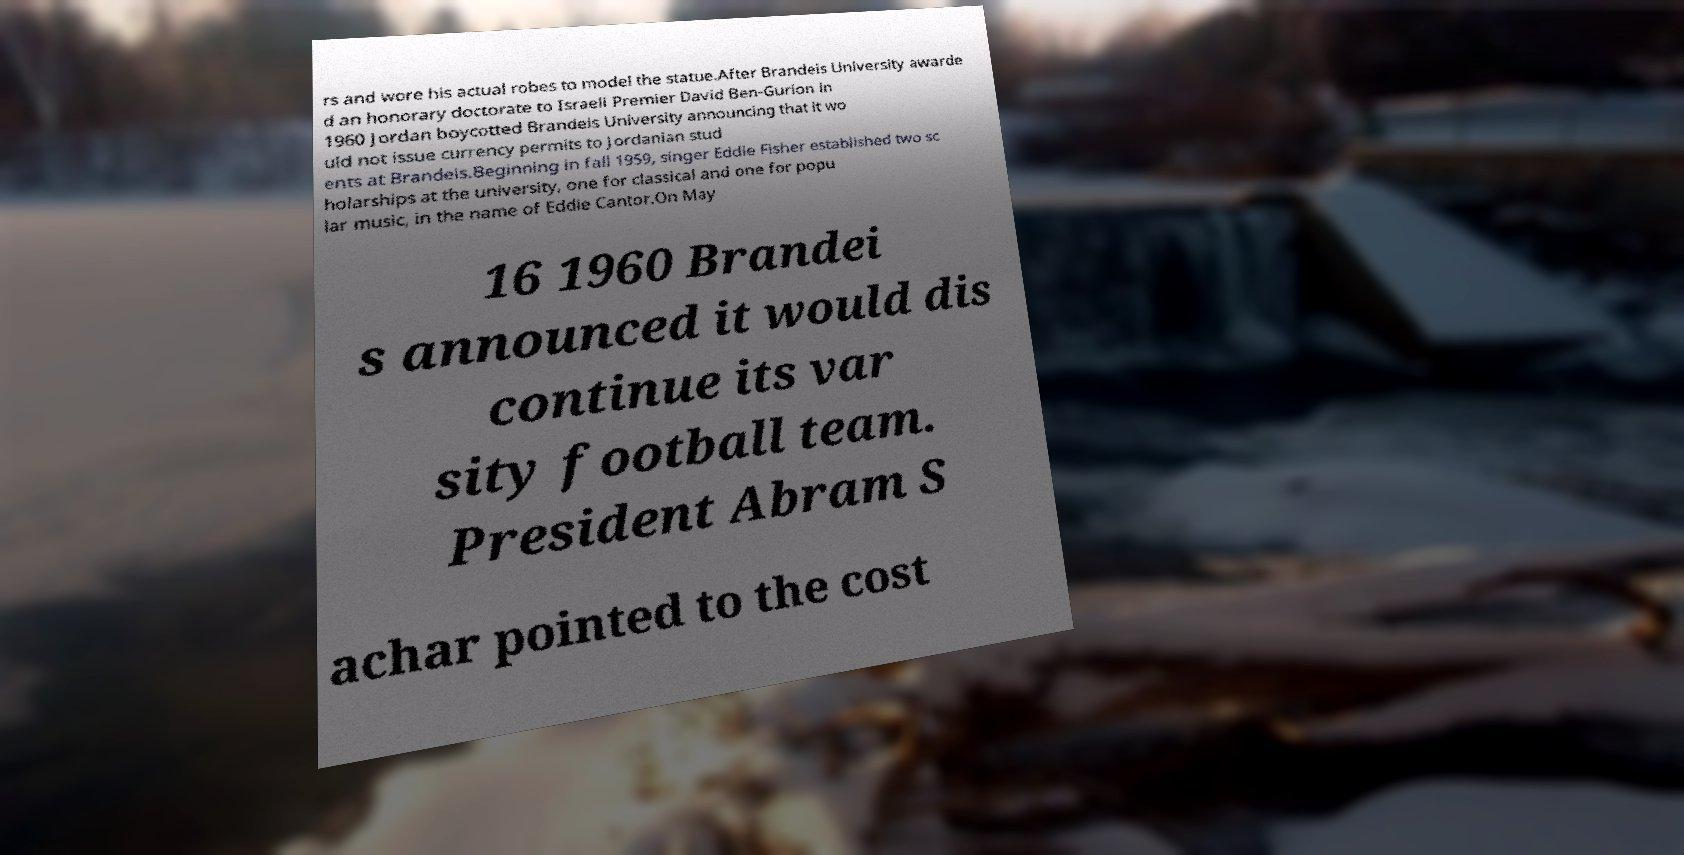For documentation purposes, I need the text within this image transcribed. Could you provide that? rs and wore his actual robes to model the statue.After Brandeis University awarde d an honorary doctorate to Israeli Premier David Ben-Gurion in 1960 Jordan boycotted Brandeis University announcing that it wo uld not issue currency permits to Jordanian stud ents at Brandeis.Beginning in fall 1959, singer Eddie Fisher established two sc holarships at the university, one for classical and one for popu lar music, in the name of Eddie Cantor.On May 16 1960 Brandei s announced it would dis continue its var sity football team. President Abram S achar pointed to the cost 